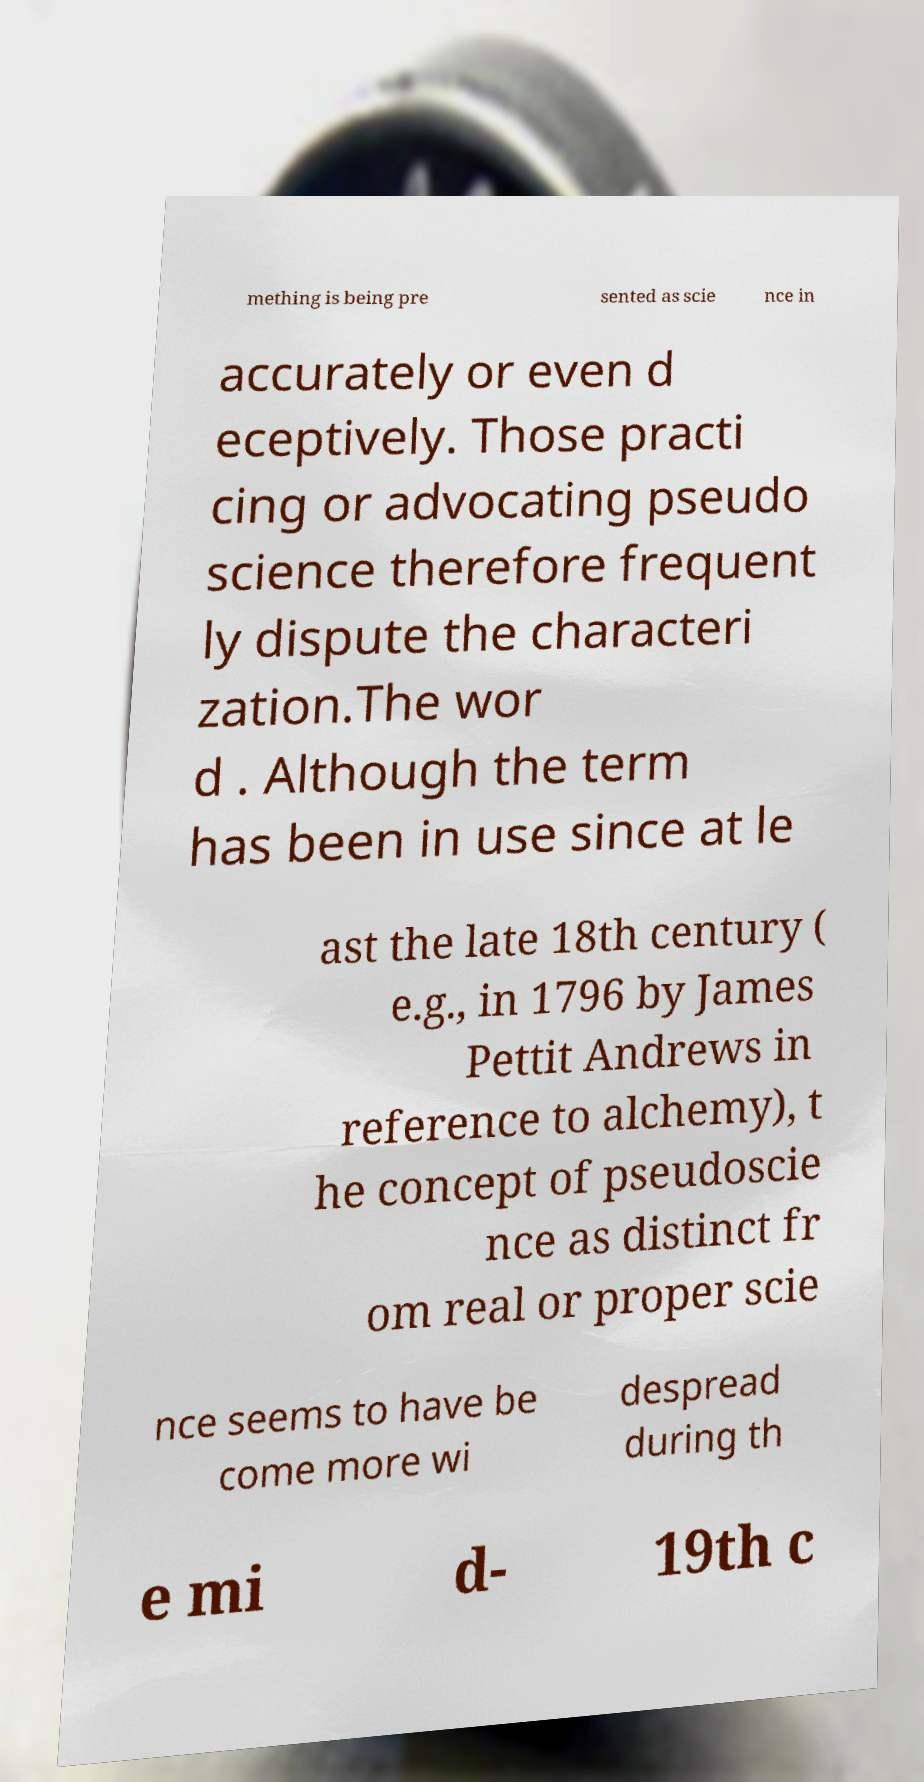What messages or text are displayed in this image? I need them in a readable, typed format. mething is being pre sented as scie nce in accurately or even d eceptively. Those practi cing or advocating pseudo science therefore frequent ly dispute the characteri zation.The wor d . Although the term has been in use since at le ast the late 18th century ( e.g., in 1796 by James Pettit Andrews in reference to alchemy), t he concept of pseudoscie nce as distinct fr om real or proper scie nce seems to have be come more wi despread during th e mi d- 19th c 